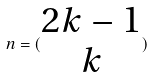Convert formula to latex. <formula><loc_0><loc_0><loc_500><loc_500>n = ( \begin{matrix} 2 k - 1 \\ k \end{matrix} )</formula> 